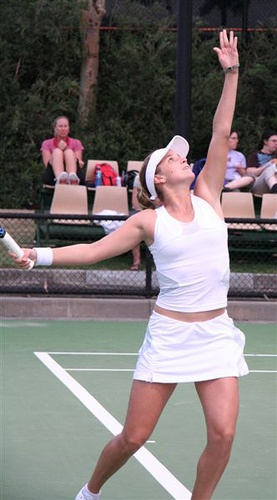Describe the objects in this image and their specific colors. I can see people in black, lavender, lightpink, brown, and darkgray tones, people in black, lightpink, brown, and violet tones, people in black, gray, and darkgray tones, people in black, violet, pink, and brown tones, and chair in black, lightpink, pink, and darkgray tones in this image. 